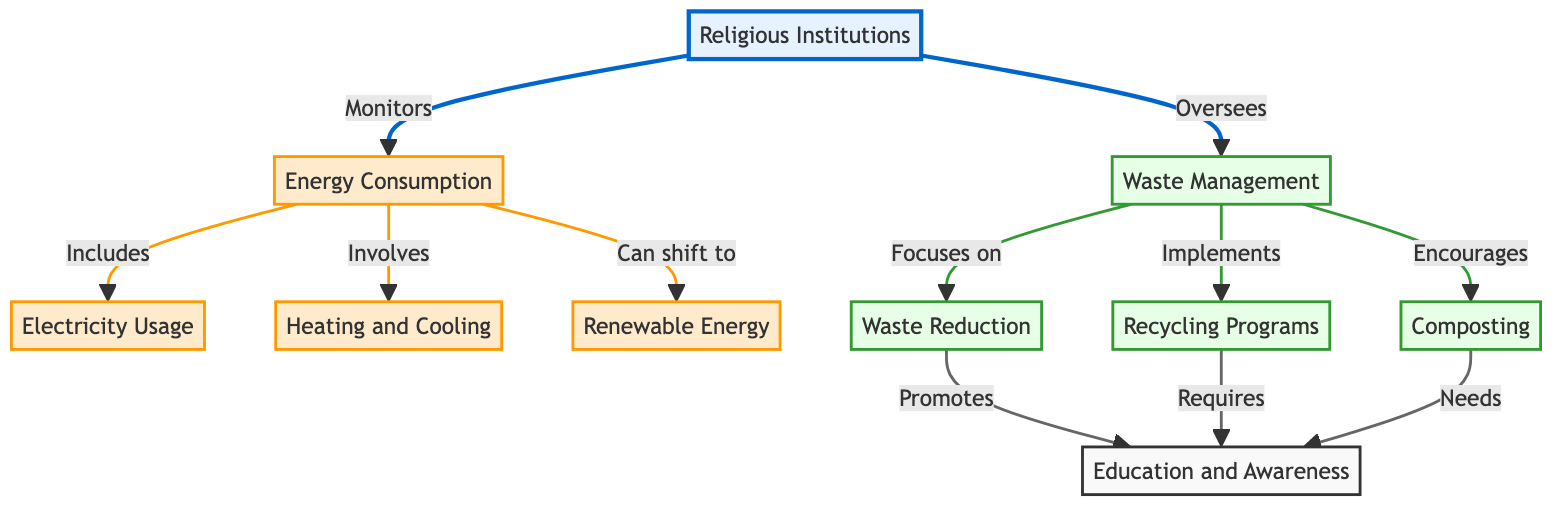What nodes does the Religious Institutions node connect to? The diagram shows that the Religious Institutions node connects to two nodes: Energy Consumption and Waste Management. This is indicated by the arrows leading from the main node to these two specific areas of focus.
Answer: Energy Consumption, Waste Management How many nodes represent waste management practices? There are four nodes that represent waste management practices in the diagram: Waste Management, Waste Reduction, Recycling Programs, and Composting. Each of these nodes is directly related to the Waste Management node.
Answer: Four What is the primary focus of waste management? The primary focus of waste management, as shown in the diagram, is Waste Reduction. This connection is evident from the arrow leading from the Waste Management node to Waste Reduction.
Answer: Waste Reduction Which node involves educating about energy consumption? The Education and Awareness node is involved in educating about energy consumption, as indicated by the arrows connecting it from Waste Reduction, Recycling Programs, and Composting, which collectively relate to energy consumption initiatives in the community.
Answer: Education and Awareness What is one way that energy consumption can shift? The diagram illustrates that Energy Consumption can shift to Renewable Energy, as indicated by the arrow that directly connects Energy Consumption to the Renewable Energy node. This indicates a potential transition in energy practices.
Answer: Renewable Energy How does Waste Reduction promote education? Waste Reduction promotes education through the Education and Awareness node, as depicted by the arrow connecting these two nodes. This implies that initiatives aimed at reducing waste also focus on educating the community.
Answer: Education and Awareness What type of management does Recycling Programs require? Recycling Programs require Education and Awareness, which is shown by the arrow from Recycling Programs to the Education and Awareness node. This indicates that effective recycling practices depend on educating the community.
Answer: Education and Awareness How many practices are directly related to Waste Management? There are three practices directly related to Waste Management: Waste Reduction, Recycling Programs, and Composting. Each of these is linked to the Waste Management node, emphasizing their roles in the broader waste management strategy.
Answer: Three What is included under Energy Consumption? Energy Consumption includes Electricity Usage and Heating and Cooling, as represented by the arrows indicating that these specific practices fall under the broader category of energy consumption.
Answer: Electricity Usage, Heating and Cooling What does the link style for energy consumption signify? The link style for energy consumption is indicated by a thicker line and a specific stroke color, which visually distinguishes the connections related to energy from those related to waste. This highlights the significance of energy nodes in the context of the overall diagram.
Answer: Thicker line, specific stroke color 